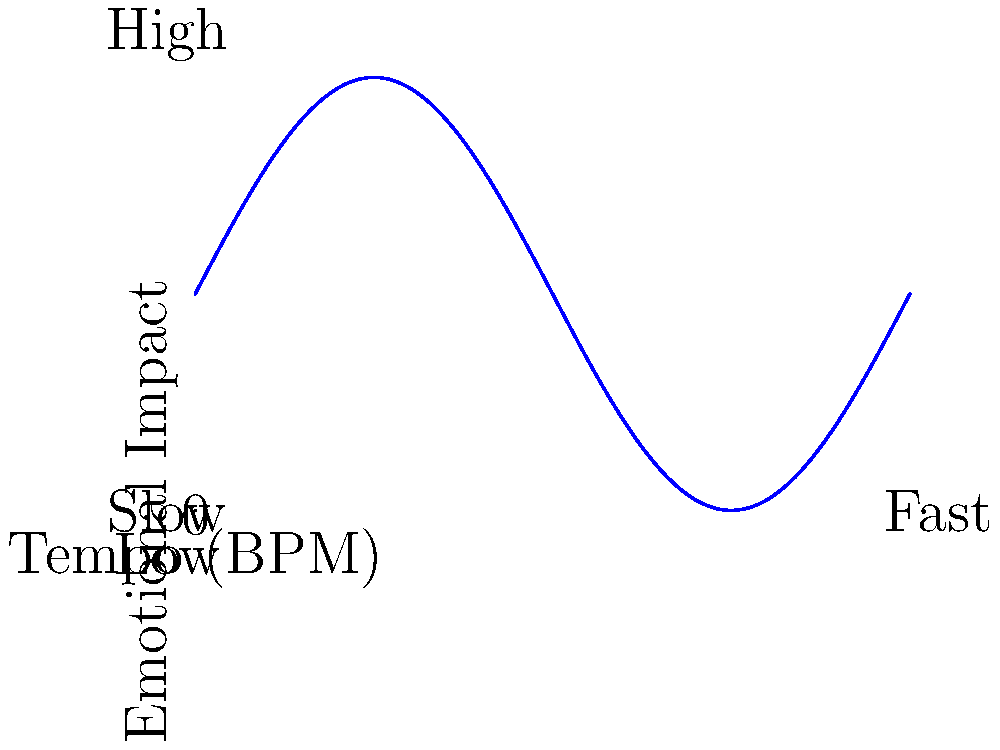Analyze the graph depicting the relationship between tempo and emotional impact in musical theatre. How does this relationship inform your approach to composing a Broadway score that effectively conveys varying emotional intensities throughout a production? 1. Graph interpretation:
   - The x-axis represents tempo (beats per minute, BPM), ranging from slow to fast.
   - The y-axis represents emotional impact, ranging from low to high.
   - The curve shows a sinusoidal relationship between tempo and emotional impact.

2. Key observations:
   - The emotional impact oscillates as the tempo increases.
   - There are multiple peaks and troughs in emotional impact across the tempo range.
   - The relationship is not linear, suggesting complex interactions between tempo and emotion.

3. Implications for Broadway composition:
   - Varied tempos can be used to create different emotional responses.
   - Both slow and fast tempos can achieve high emotional impact at certain points.
   - Moderate tempos may result in lower emotional impact, depending on their position in the cycle.

4. Application in score composition:
   - Use slower tempos for introspective or melancholic scenes, aligning with emotional peaks.
   - Employ faster tempos for energetic or climactic moments, corresponding to high-impact points.
   - Strategically place moderate tempos for transitional or less emotionally charged scenes.

5. Dynamic scoring:
   - Vary tempos throughout the production to maintain audience engagement.
   - Align tempo changes with the emotional arc of the story and character development.
   - Use the graph as a guide to create a balanced emotional journey through music.

6. Considerations for emotional nuance:
   - Recognize that tempo is just one factor in emotional impact; also consider harmony, instrumentation, and lyrics.
   - Use the graph as a starting point, but allow for creative interpretation and experimentation.

7. Broadway-specific applications:
   - Consider the physical demands on performers when choosing tempos for dance numbers.
   - Balance the need for emotional impact with the clarity of lyrics in narrative songs.
   - Use tempo variations to differentiate between character themes or leitmotifs.
Answer: Utilize varying tempos strategically to create a dynamic emotional landscape, aligning peaks of the tempo-emotion curve with key dramatic moments in the Broadway production. 